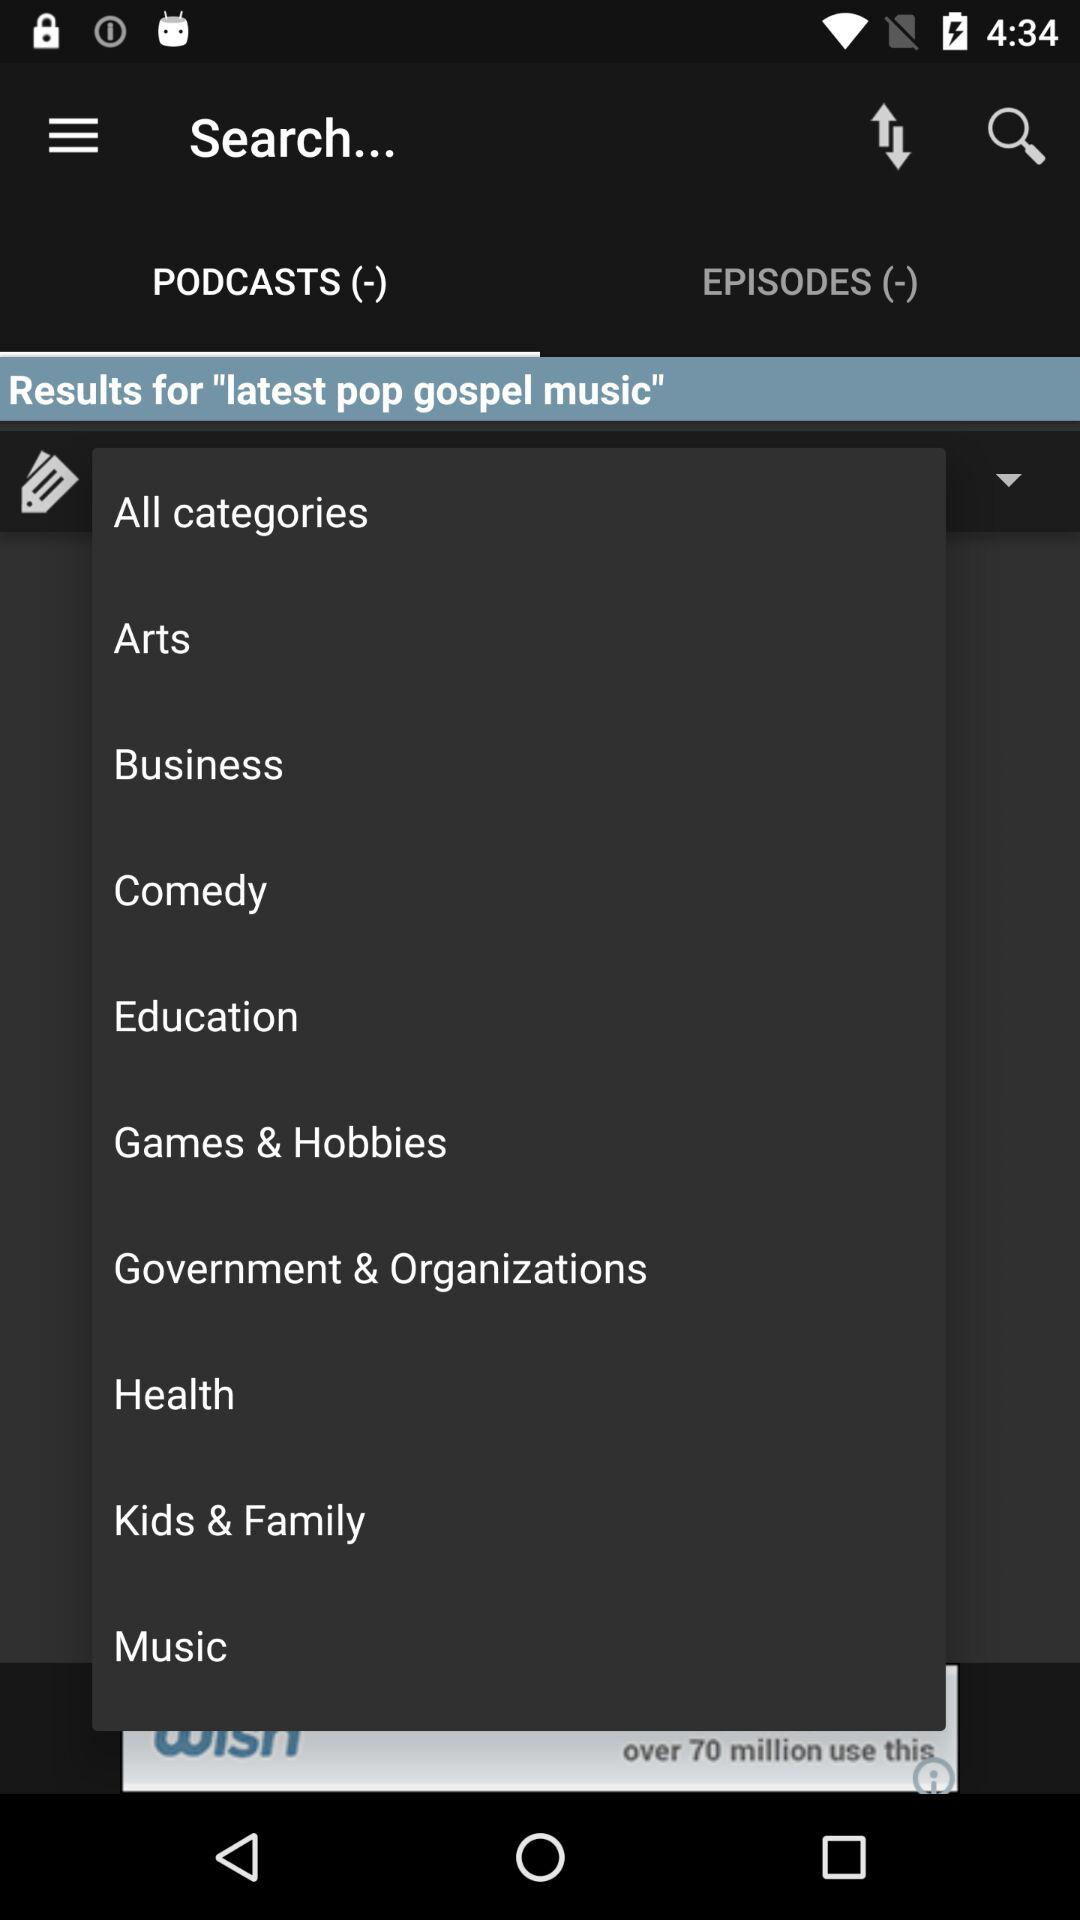Which tab is selected? The selected tab is "PODCASTS (-)". 